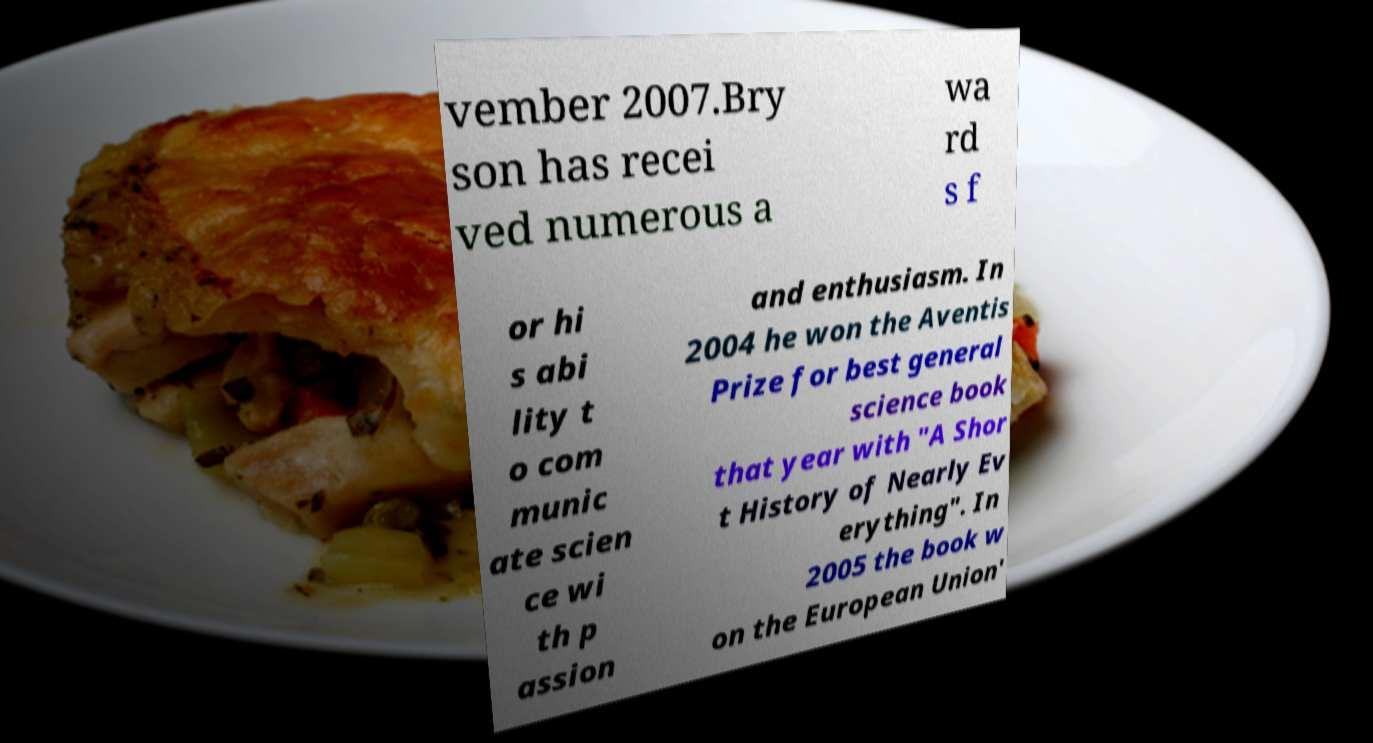Please read and relay the text visible in this image. What does it say? vember 2007.Bry son has recei ved numerous a wa rd s f or hi s abi lity t o com munic ate scien ce wi th p assion and enthusiasm. In 2004 he won the Aventis Prize for best general science book that year with "A Shor t History of Nearly Ev erything". In 2005 the book w on the European Union' 